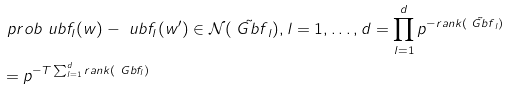Convert formula to latex. <formula><loc_0><loc_0><loc_500><loc_500>& \ p r o b { \ u b f _ { l } ( w ) - \ u b f _ { l } ( w ^ { \prime } ) \in \mathcal { N } ( \tilde { \ G b f } _ { l } ) , l = 1 , \dots , d } = \prod _ { l = 1 } ^ { d } p ^ { - r a n k ( \tilde { \ G b f } _ { l } ) } \\ & = p ^ { - T \sum _ { l = 1 } ^ { d } r a n k ( \ G b f _ { l } ) }</formula> 